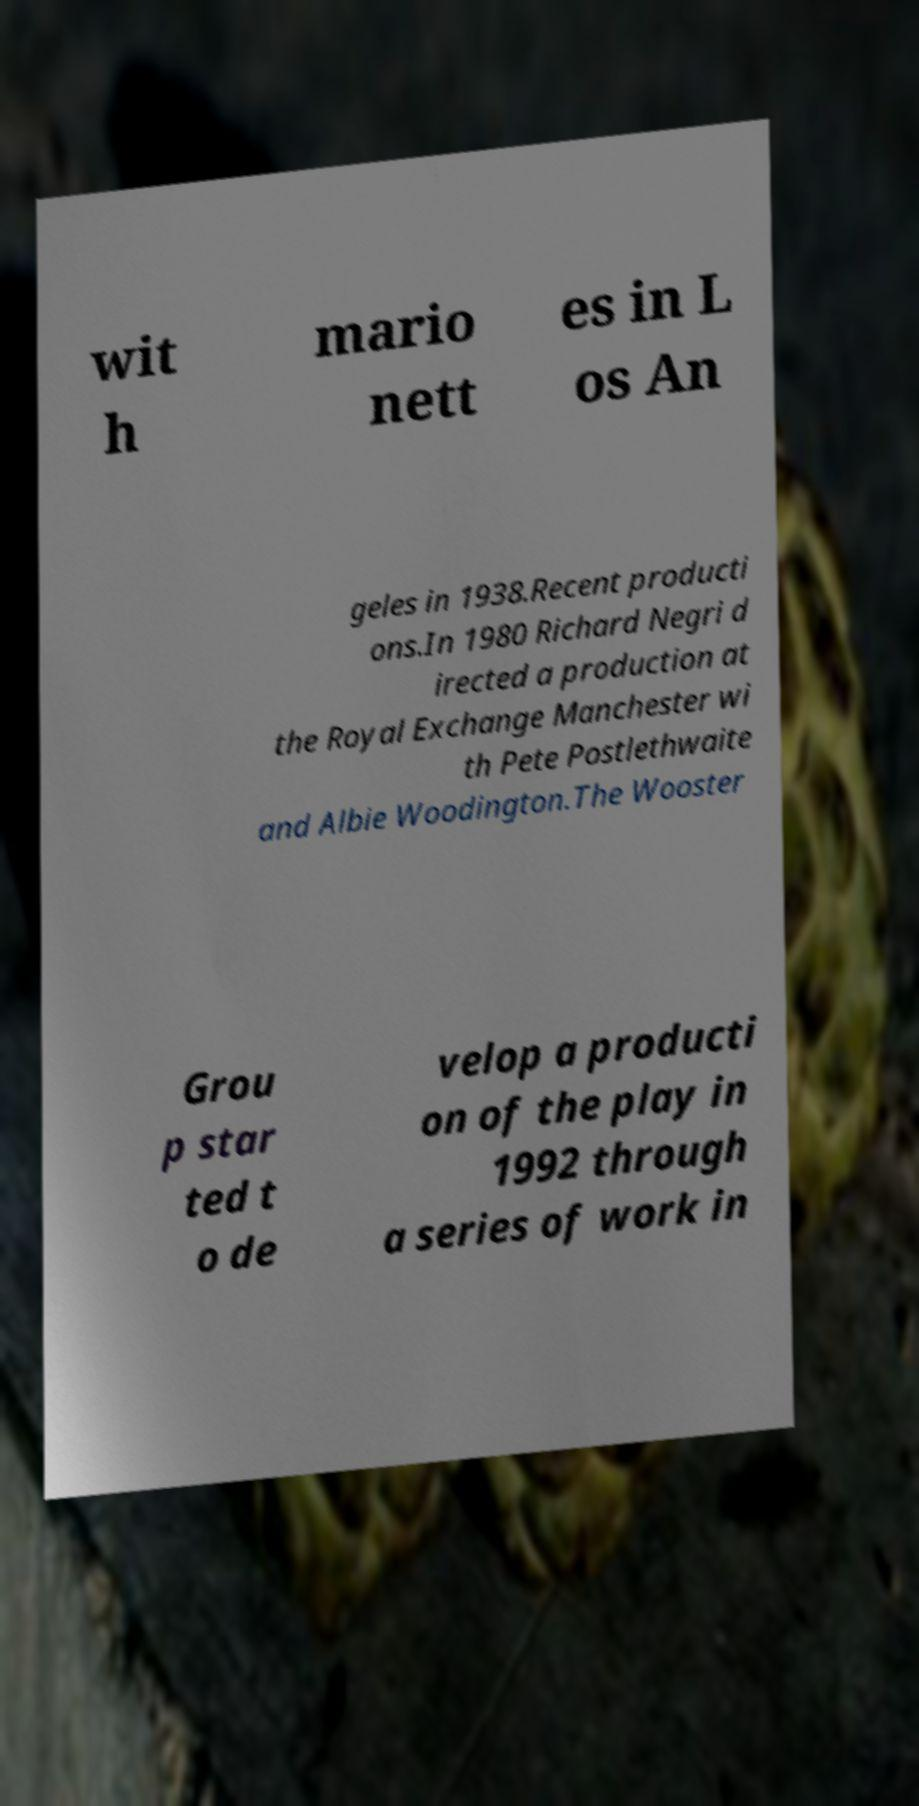I need the written content from this picture converted into text. Can you do that? wit h mario nett es in L os An geles in 1938.Recent producti ons.In 1980 Richard Negri d irected a production at the Royal Exchange Manchester wi th Pete Postlethwaite and Albie Woodington.The Wooster Grou p star ted t o de velop a producti on of the play in 1992 through a series of work in 